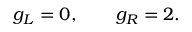Convert formula to latex. <formula><loc_0><loc_0><loc_500><loc_500>g _ { L } = 0 , \quad \ \ g _ { R } = 2 .</formula> 